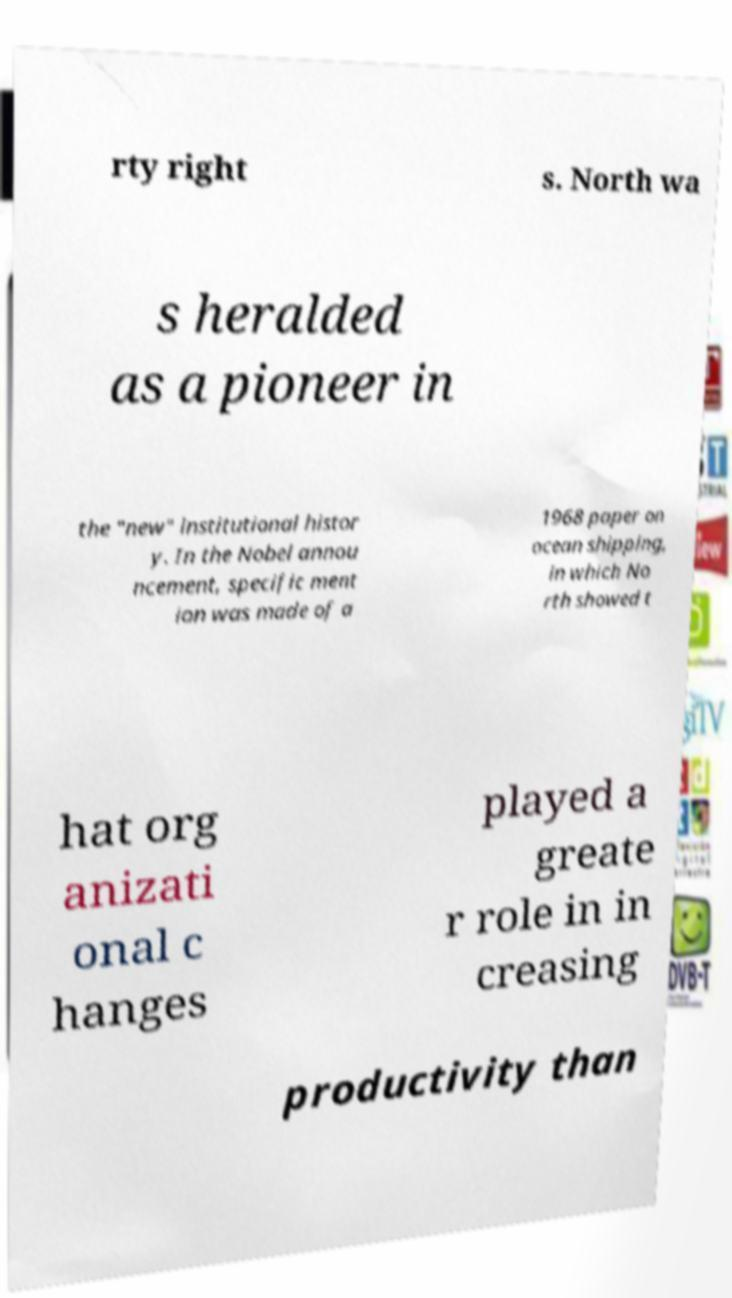What messages or text are displayed in this image? I need them in a readable, typed format. rty right s. North wa s heralded as a pioneer in the "new" institutional histor y. In the Nobel annou ncement, specific ment ion was made of a 1968 paper on ocean shipping, in which No rth showed t hat org anizati onal c hanges played a greate r role in in creasing productivity than 